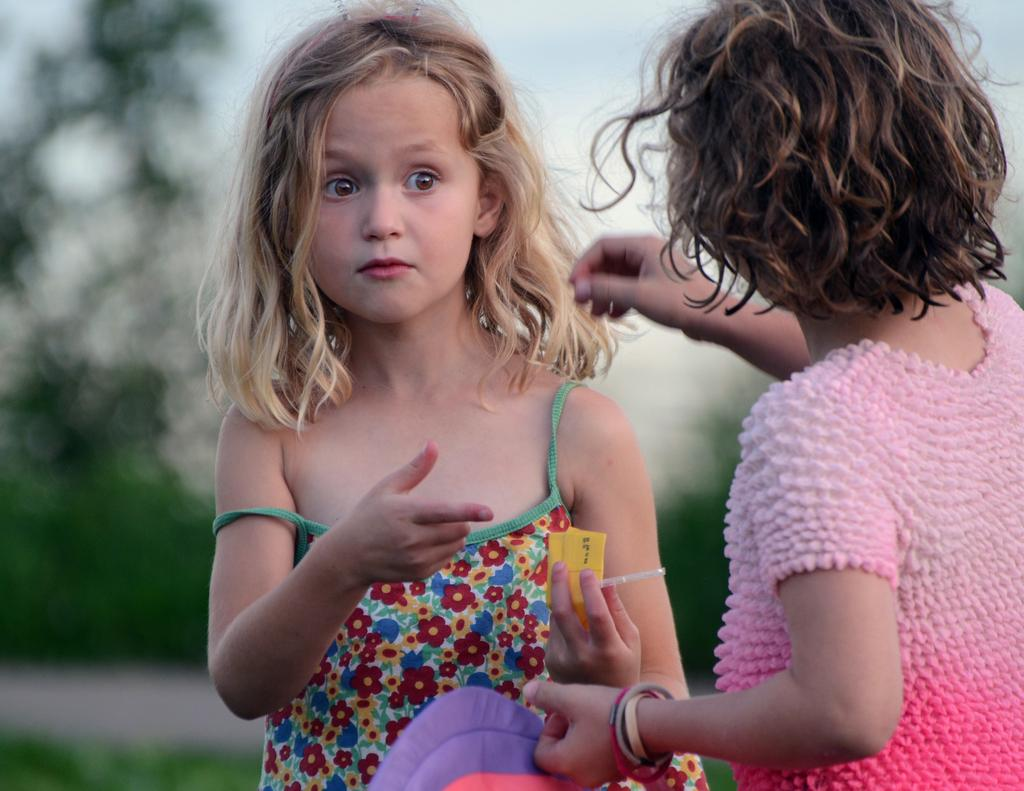What is the girl in the image holding? There is a girl holding an object in the image. Can you describe the other girl in the image? There is another girl standing in the image. What can be observed about the background of the image? The background of the image is blurred. What type of education can be seen taking place on the coast in the image? There is no education or coast present in the image; it features two girls and a blurred background. 